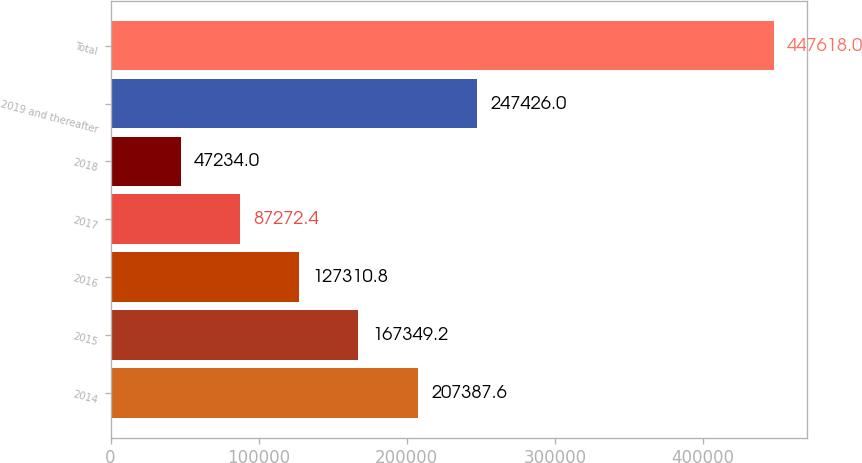Convert chart to OTSL. <chart><loc_0><loc_0><loc_500><loc_500><bar_chart><fcel>2014<fcel>2015<fcel>2016<fcel>2017<fcel>2018<fcel>2019 and thereafter<fcel>Total<nl><fcel>207388<fcel>167349<fcel>127311<fcel>87272.4<fcel>47234<fcel>247426<fcel>447618<nl></chart> 